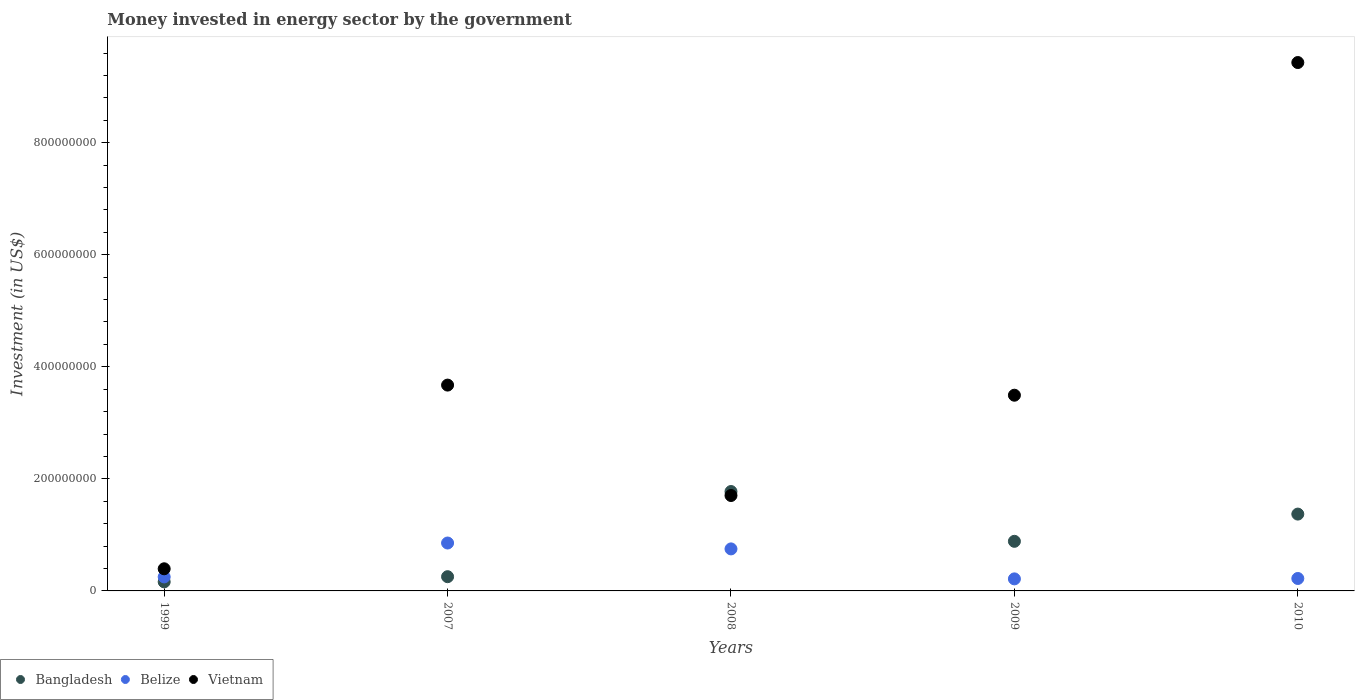How many different coloured dotlines are there?
Your answer should be compact. 3. Is the number of dotlines equal to the number of legend labels?
Your answer should be compact. Yes. What is the money spent in energy sector in Bangladesh in 2008?
Offer a terse response. 1.77e+08. Across all years, what is the maximum money spent in energy sector in Vietnam?
Provide a short and direct response. 9.43e+08. Across all years, what is the minimum money spent in energy sector in Belize?
Ensure brevity in your answer.  2.15e+07. What is the total money spent in energy sector in Belize in the graph?
Your response must be concise. 2.29e+08. What is the difference between the money spent in energy sector in Belize in 1999 and that in 2008?
Make the answer very short. -5.00e+07. What is the difference between the money spent in energy sector in Vietnam in 1999 and the money spent in energy sector in Bangladesh in 2008?
Your response must be concise. -1.38e+08. What is the average money spent in energy sector in Belize per year?
Give a very brief answer. 4.58e+07. In the year 2010, what is the difference between the money spent in energy sector in Vietnam and money spent in energy sector in Bangladesh?
Keep it short and to the point. 8.06e+08. In how many years, is the money spent in energy sector in Bangladesh greater than 800000000 US$?
Keep it short and to the point. 0. What is the ratio of the money spent in energy sector in Bangladesh in 2008 to that in 2009?
Provide a succinct answer. 2. Is the difference between the money spent in energy sector in Vietnam in 2008 and 2009 greater than the difference between the money spent in energy sector in Bangladesh in 2008 and 2009?
Offer a very short reply. No. What is the difference between the highest and the second highest money spent in energy sector in Bangladesh?
Make the answer very short. 4.03e+07. What is the difference between the highest and the lowest money spent in energy sector in Belize?
Ensure brevity in your answer.  6.40e+07. Is it the case that in every year, the sum of the money spent in energy sector in Vietnam and money spent in energy sector in Belize  is greater than the money spent in energy sector in Bangladesh?
Keep it short and to the point. Yes. Does the money spent in energy sector in Bangladesh monotonically increase over the years?
Give a very brief answer. No. What is the difference between two consecutive major ticks on the Y-axis?
Give a very brief answer. 2.00e+08. Are the values on the major ticks of Y-axis written in scientific E-notation?
Provide a succinct answer. No. Does the graph contain any zero values?
Your response must be concise. No. How many legend labels are there?
Provide a succinct answer. 3. What is the title of the graph?
Offer a very short reply. Money invested in energy sector by the government. Does "Namibia" appear as one of the legend labels in the graph?
Your response must be concise. No. What is the label or title of the X-axis?
Ensure brevity in your answer.  Years. What is the label or title of the Y-axis?
Give a very brief answer. Investment (in US$). What is the Investment (in US$) of Bangladesh in 1999?
Ensure brevity in your answer.  1.62e+07. What is the Investment (in US$) in Belize in 1999?
Provide a short and direct response. 2.50e+07. What is the Investment (in US$) in Vietnam in 1999?
Your response must be concise. 3.95e+07. What is the Investment (in US$) in Bangladesh in 2007?
Ensure brevity in your answer.  2.54e+07. What is the Investment (in US$) in Belize in 2007?
Your answer should be compact. 8.55e+07. What is the Investment (in US$) in Vietnam in 2007?
Keep it short and to the point. 3.67e+08. What is the Investment (in US$) of Bangladesh in 2008?
Give a very brief answer. 1.77e+08. What is the Investment (in US$) of Belize in 2008?
Provide a short and direct response. 7.50e+07. What is the Investment (in US$) in Vietnam in 2008?
Give a very brief answer. 1.70e+08. What is the Investment (in US$) of Bangladesh in 2009?
Your answer should be very brief. 8.85e+07. What is the Investment (in US$) in Belize in 2009?
Ensure brevity in your answer.  2.15e+07. What is the Investment (in US$) in Vietnam in 2009?
Your response must be concise. 3.49e+08. What is the Investment (in US$) in Bangladesh in 2010?
Provide a short and direct response. 1.37e+08. What is the Investment (in US$) in Belize in 2010?
Offer a very short reply. 2.22e+07. What is the Investment (in US$) of Vietnam in 2010?
Provide a succinct answer. 9.43e+08. Across all years, what is the maximum Investment (in US$) in Bangladesh?
Keep it short and to the point. 1.77e+08. Across all years, what is the maximum Investment (in US$) of Belize?
Offer a terse response. 8.55e+07. Across all years, what is the maximum Investment (in US$) in Vietnam?
Offer a very short reply. 9.43e+08. Across all years, what is the minimum Investment (in US$) of Bangladesh?
Give a very brief answer. 1.62e+07. Across all years, what is the minimum Investment (in US$) in Belize?
Ensure brevity in your answer.  2.15e+07. Across all years, what is the minimum Investment (in US$) of Vietnam?
Provide a succinct answer. 3.95e+07. What is the total Investment (in US$) of Bangladesh in the graph?
Ensure brevity in your answer.  4.45e+08. What is the total Investment (in US$) of Belize in the graph?
Give a very brief answer. 2.29e+08. What is the total Investment (in US$) in Vietnam in the graph?
Your answer should be very brief. 1.87e+09. What is the difference between the Investment (in US$) in Bangladesh in 1999 and that in 2007?
Offer a terse response. -9.25e+06. What is the difference between the Investment (in US$) of Belize in 1999 and that in 2007?
Provide a succinct answer. -6.05e+07. What is the difference between the Investment (in US$) of Vietnam in 1999 and that in 2007?
Ensure brevity in your answer.  -3.28e+08. What is the difference between the Investment (in US$) of Bangladesh in 1999 and that in 2008?
Ensure brevity in your answer.  -1.61e+08. What is the difference between the Investment (in US$) of Belize in 1999 and that in 2008?
Offer a terse response. -5.00e+07. What is the difference between the Investment (in US$) of Vietnam in 1999 and that in 2008?
Your answer should be very brief. -1.31e+08. What is the difference between the Investment (in US$) of Bangladesh in 1999 and that in 2009?
Offer a terse response. -7.24e+07. What is the difference between the Investment (in US$) in Belize in 1999 and that in 2009?
Give a very brief answer. 3.50e+06. What is the difference between the Investment (in US$) in Vietnam in 1999 and that in 2009?
Your answer should be compact. -3.10e+08. What is the difference between the Investment (in US$) in Bangladesh in 1999 and that in 2010?
Provide a succinct answer. -1.21e+08. What is the difference between the Investment (in US$) of Belize in 1999 and that in 2010?
Offer a terse response. 2.80e+06. What is the difference between the Investment (in US$) in Vietnam in 1999 and that in 2010?
Your answer should be compact. -9.04e+08. What is the difference between the Investment (in US$) of Bangladesh in 2007 and that in 2008?
Provide a short and direct response. -1.52e+08. What is the difference between the Investment (in US$) in Belize in 2007 and that in 2008?
Make the answer very short. 1.05e+07. What is the difference between the Investment (in US$) of Vietnam in 2007 and that in 2008?
Your answer should be compact. 1.97e+08. What is the difference between the Investment (in US$) of Bangladesh in 2007 and that in 2009?
Provide a short and direct response. -6.31e+07. What is the difference between the Investment (in US$) of Belize in 2007 and that in 2009?
Offer a very short reply. 6.40e+07. What is the difference between the Investment (in US$) in Vietnam in 2007 and that in 2009?
Make the answer very short. 1.81e+07. What is the difference between the Investment (in US$) of Bangladesh in 2007 and that in 2010?
Offer a terse response. -1.12e+08. What is the difference between the Investment (in US$) of Belize in 2007 and that in 2010?
Your answer should be compact. 6.33e+07. What is the difference between the Investment (in US$) in Vietnam in 2007 and that in 2010?
Offer a very short reply. -5.76e+08. What is the difference between the Investment (in US$) in Bangladesh in 2008 and that in 2009?
Offer a very short reply. 8.89e+07. What is the difference between the Investment (in US$) of Belize in 2008 and that in 2009?
Provide a succinct answer. 5.35e+07. What is the difference between the Investment (in US$) in Vietnam in 2008 and that in 2009?
Your answer should be compact. -1.79e+08. What is the difference between the Investment (in US$) of Bangladesh in 2008 and that in 2010?
Your response must be concise. 4.03e+07. What is the difference between the Investment (in US$) of Belize in 2008 and that in 2010?
Ensure brevity in your answer.  5.28e+07. What is the difference between the Investment (in US$) in Vietnam in 2008 and that in 2010?
Provide a succinct answer. -7.73e+08. What is the difference between the Investment (in US$) in Bangladesh in 2009 and that in 2010?
Provide a succinct answer. -4.86e+07. What is the difference between the Investment (in US$) in Belize in 2009 and that in 2010?
Offer a very short reply. -7.00e+05. What is the difference between the Investment (in US$) in Vietnam in 2009 and that in 2010?
Your answer should be very brief. -5.94e+08. What is the difference between the Investment (in US$) of Bangladesh in 1999 and the Investment (in US$) of Belize in 2007?
Make the answer very short. -6.94e+07. What is the difference between the Investment (in US$) of Bangladesh in 1999 and the Investment (in US$) of Vietnam in 2007?
Your answer should be compact. -3.51e+08. What is the difference between the Investment (in US$) of Belize in 1999 and the Investment (in US$) of Vietnam in 2007?
Make the answer very short. -3.42e+08. What is the difference between the Investment (in US$) of Bangladesh in 1999 and the Investment (in US$) of Belize in 2008?
Provide a succinct answer. -5.88e+07. What is the difference between the Investment (in US$) of Bangladesh in 1999 and the Investment (in US$) of Vietnam in 2008?
Offer a terse response. -1.54e+08. What is the difference between the Investment (in US$) in Belize in 1999 and the Investment (in US$) in Vietnam in 2008?
Provide a succinct answer. -1.45e+08. What is the difference between the Investment (in US$) in Bangladesh in 1999 and the Investment (in US$) in Belize in 2009?
Ensure brevity in your answer.  -5.35e+06. What is the difference between the Investment (in US$) of Bangladesh in 1999 and the Investment (in US$) of Vietnam in 2009?
Provide a short and direct response. -3.33e+08. What is the difference between the Investment (in US$) in Belize in 1999 and the Investment (in US$) in Vietnam in 2009?
Give a very brief answer. -3.24e+08. What is the difference between the Investment (in US$) in Bangladesh in 1999 and the Investment (in US$) in Belize in 2010?
Keep it short and to the point. -6.05e+06. What is the difference between the Investment (in US$) in Bangladesh in 1999 and the Investment (in US$) in Vietnam in 2010?
Ensure brevity in your answer.  -9.27e+08. What is the difference between the Investment (in US$) in Belize in 1999 and the Investment (in US$) in Vietnam in 2010?
Your answer should be compact. -9.18e+08. What is the difference between the Investment (in US$) of Bangladesh in 2007 and the Investment (in US$) of Belize in 2008?
Your answer should be very brief. -4.96e+07. What is the difference between the Investment (in US$) in Bangladesh in 2007 and the Investment (in US$) in Vietnam in 2008?
Your answer should be compact. -1.45e+08. What is the difference between the Investment (in US$) of Belize in 2007 and the Investment (in US$) of Vietnam in 2008?
Your answer should be very brief. -8.48e+07. What is the difference between the Investment (in US$) of Bangladesh in 2007 and the Investment (in US$) of Belize in 2009?
Give a very brief answer. 3.90e+06. What is the difference between the Investment (in US$) of Bangladesh in 2007 and the Investment (in US$) of Vietnam in 2009?
Ensure brevity in your answer.  -3.24e+08. What is the difference between the Investment (in US$) of Belize in 2007 and the Investment (in US$) of Vietnam in 2009?
Your answer should be compact. -2.64e+08. What is the difference between the Investment (in US$) in Bangladesh in 2007 and the Investment (in US$) in Belize in 2010?
Keep it short and to the point. 3.20e+06. What is the difference between the Investment (in US$) in Bangladesh in 2007 and the Investment (in US$) in Vietnam in 2010?
Your answer should be very brief. -9.18e+08. What is the difference between the Investment (in US$) of Belize in 2007 and the Investment (in US$) of Vietnam in 2010?
Make the answer very short. -8.58e+08. What is the difference between the Investment (in US$) in Bangladesh in 2008 and the Investment (in US$) in Belize in 2009?
Make the answer very short. 1.56e+08. What is the difference between the Investment (in US$) in Bangladesh in 2008 and the Investment (in US$) in Vietnam in 2009?
Your answer should be very brief. -1.72e+08. What is the difference between the Investment (in US$) in Belize in 2008 and the Investment (in US$) in Vietnam in 2009?
Provide a succinct answer. -2.74e+08. What is the difference between the Investment (in US$) of Bangladesh in 2008 and the Investment (in US$) of Belize in 2010?
Give a very brief answer. 1.55e+08. What is the difference between the Investment (in US$) in Bangladesh in 2008 and the Investment (in US$) in Vietnam in 2010?
Offer a very short reply. -7.66e+08. What is the difference between the Investment (in US$) of Belize in 2008 and the Investment (in US$) of Vietnam in 2010?
Give a very brief answer. -8.68e+08. What is the difference between the Investment (in US$) of Bangladesh in 2009 and the Investment (in US$) of Belize in 2010?
Provide a succinct answer. 6.63e+07. What is the difference between the Investment (in US$) in Bangladesh in 2009 and the Investment (in US$) in Vietnam in 2010?
Ensure brevity in your answer.  -8.55e+08. What is the difference between the Investment (in US$) in Belize in 2009 and the Investment (in US$) in Vietnam in 2010?
Give a very brief answer. -9.22e+08. What is the average Investment (in US$) of Bangladesh per year?
Ensure brevity in your answer.  8.89e+07. What is the average Investment (in US$) of Belize per year?
Provide a short and direct response. 4.58e+07. What is the average Investment (in US$) in Vietnam per year?
Offer a terse response. 3.74e+08. In the year 1999, what is the difference between the Investment (in US$) in Bangladesh and Investment (in US$) in Belize?
Provide a short and direct response. -8.85e+06. In the year 1999, what is the difference between the Investment (in US$) in Bangladesh and Investment (in US$) in Vietnam?
Provide a succinct answer. -2.34e+07. In the year 1999, what is the difference between the Investment (in US$) of Belize and Investment (in US$) of Vietnam?
Ensure brevity in your answer.  -1.45e+07. In the year 2007, what is the difference between the Investment (in US$) in Bangladesh and Investment (in US$) in Belize?
Ensure brevity in your answer.  -6.01e+07. In the year 2007, what is the difference between the Investment (in US$) in Bangladesh and Investment (in US$) in Vietnam?
Make the answer very short. -3.42e+08. In the year 2007, what is the difference between the Investment (in US$) of Belize and Investment (in US$) of Vietnam?
Give a very brief answer. -2.82e+08. In the year 2008, what is the difference between the Investment (in US$) of Bangladesh and Investment (in US$) of Belize?
Provide a short and direct response. 1.02e+08. In the year 2008, what is the difference between the Investment (in US$) in Bangladesh and Investment (in US$) in Vietnam?
Ensure brevity in your answer.  7.10e+06. In the year 2008, what is the difference between the Investment (in US$) in Belize and Investment (in US$) in Vietnam?
Provide a short and direct response. -9.53e+07. In the year 2009, what is the difference between the Investment (in US$) of Bangladesh and Investment (in US$) of Belize?
Offer a very short reply. 6.70e+07. In the year 2009, what is the difference between the Investment (in US$) of Bangladesh and Investment (in US$) of Vietnam?
Your response must be concise. -2.61e+08. In the year 2009, what is the difference between the Investment (in US$) in Belize and Investment (in US$) in Vietnam?
Your answer should be very brief. -3.28e+08. In the year 2010, what is the difference between the Investment (in US$) of Bangladesh and Investment (in US$) of Belize?
Provide a short and direct response. 1.15e+08. In the year 2010, what is the difference between the Investment (in US$) in Bangladesh and Investment (in US$) in Vietnam?
Provide a succinct answer. -8.06e+08. In the year 2010, what is the difference between the Investment (in US$) in Belize and Investment (in US$) in Vietnam?
Offer a very short reply. -9.21e+08. What is the ratio of the Investment (in US$) of Bangladesh in 1999 to that in 2007?
Provide a succinct answer. 0.64. What is the ratio of the Investment (in US$) of Belize in 1999 to that in 2007?
Your answer should be very brief. 0.29. What is the ratio of the Investment (in US$) of Vietnam in 1999 to that in 2007?
Provide a short and direct response. 0.11. What is the ratio of the Investment (in US$) in Bangladesh in 1999 to that in 2008?
Keep it short and to the point. 0.09. What is the ratio of the Investment (in US$) of Vietnam in 1999 to that in 2008?
Your answer should be very brief. 0.23. What is the ratio of the Investment (in US$) of Bangladesh in 1999 to that in 2009?
Make the answer very short. 0.18. What is the ratio of the Investment (in US$) in Belize in 1999 to that in 2009?
Offer a terse response. 1.16. What is the ratio of the Investment (in US$) of Vietnam in 1999 to that in 2009?
Your answer should be very brief. 0.11. What is the ratio of the Investment (in US$) of Bangladesh in 1999 to that in 2010?
Ensure brevity in your answer.  0.12. What is the ratio of the Investment (in US$) of Belize in 1999 to that in 2010?
Offer a very short reply. 1.13. What is the ratio of the Investment (in US$) in Vietnam in 1999 to that in 2010?
Keep it short and to the point. 0.04. What is the ratio of the Investment (in US$) of Bangladesh in 2007 to that in 2008?
Offer a terse response. 0.14. What is the ratio of the Investment (in US$) of Belize in 2007 to that in 2008?
Offer a terse response. 1.14. What is the ratio of the Investment (in US$) of Vietnam in 2007 to that in 2008?
Provide a succinct answer. 2.16. What is the ratio of the Investment (in US$) in Bangladesh in 2007 to that in 2009?
Keep it short and to the point. 0.29. What is the ratio of the Investment (in US$) of Belize in 2007 to that in 2009?
Provide a short and direct response. 3.98. What is the ratio of the Investment (in US$) of Vietnam in 2007 to that in 2009?
Give a very brief answer. 1.05. What is the ratio of the Investment (in US$) of Bangladesh in 2007 to that in 2010?
Make the answer very short. 0.19. What is the ratio of the Investment (in US$) in Belize in 2007 to that in 2010?
Your answer should be very brief. 3.85. What is the ratio of the Investment (in US$) in Vietnam in 2007 to that in 2010?
Give a very brief answer. 0.39. What is the ratio of the Investment (in US$) in Bangladesh in 2008 to that in 2009?
Your answer should be very brief. 2. What is the ratio of the Investment (in US$) in Belize in 2008 to that in 2009?
Your response must be concise. 3.49. What is the ratio of the Investment (in US$) of Vietnam in 2008 to that in 2009?
Your answer should be compact. 0.49. What is the ratio of the Investment (in US$) of Bangladesh in 2008 to that in 2010?
Make the answer very short. 1.29. What is the ratio of the Investment (in US$) in Belize in 2008 to that in 2010?
Give a very brief answer. 3.38. What is the ratio of the Investment (in US$) in Vietnam in 2008 to that in 2010?
Keep it short and to the point. 0.18. What is the ratio of the Investment (in US$) in Bangladesh in 2009 to that in 2010?
Make the answer very short. 0.65. What is the ratio of the Investment (in US$) in Belize in 2009 to that in 2010?
Ensure brevity in your answer.  0.97. What is the ratio of the Investment (in US$) of Vietnam in 2009 to that in 2010?
Your answer should be very brief. 0.37. What is the difference between the highest and the second highest Investment (in US$) of Bangladesh?
Provide a succinct answer. 4.03e+07. What is the difference between the highest and the second highest Investment (in US$) in Belize?
Give a very brief answer. 1.05e+07. What is the difference between the highest and the second highest Investment (in US$) of Vietnam?
Ensure brevity in your answer.  5.76e+08. What is the difference between the highest and the lowest Investment (in US$) in Bangladesh?
Keep it short and to the point. 1.61e+08. What is the difference between the highest and the lowest Investment (in US$) in Belize?
Your response must be concise. 6.40e+07. What is the difference between the highest and the lowest Investment (in US$) in Vietnam?
Provide a succinct answer. 9.04e+08. 